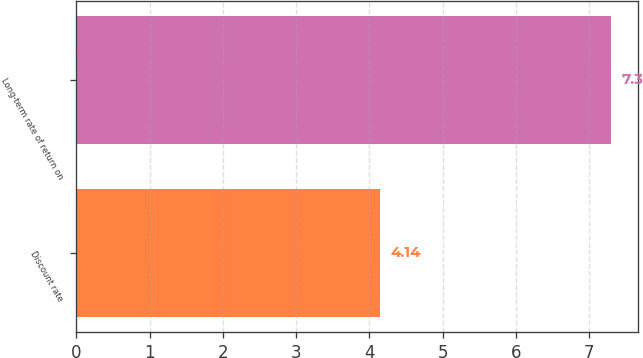<chart> <loc_0><loc_0><loc_500><loc_500><bar_chart><fcel>Discount rate<fcel>Long-term rate of return on<nl><fcel>4.14<fcel>7.3<nl></chart> 